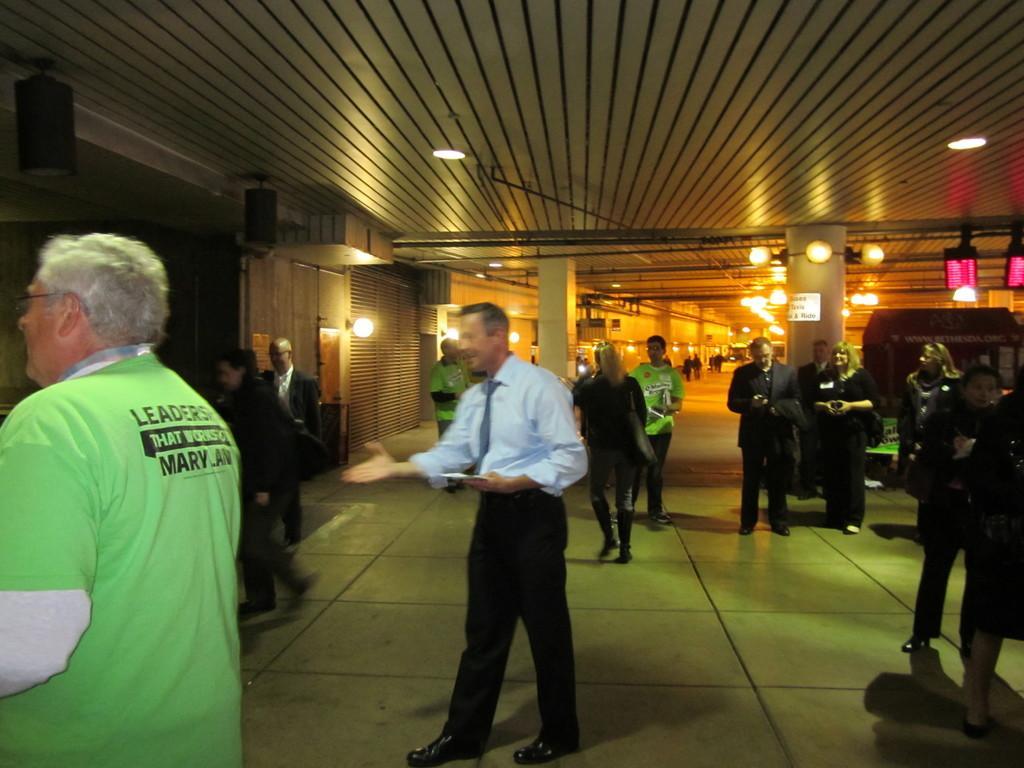Describe this image in one or two sentences. In the middle a man is walking, he wore shirt, trouser,tie. On the left side there is another man, he wore a green color t-shirt. 